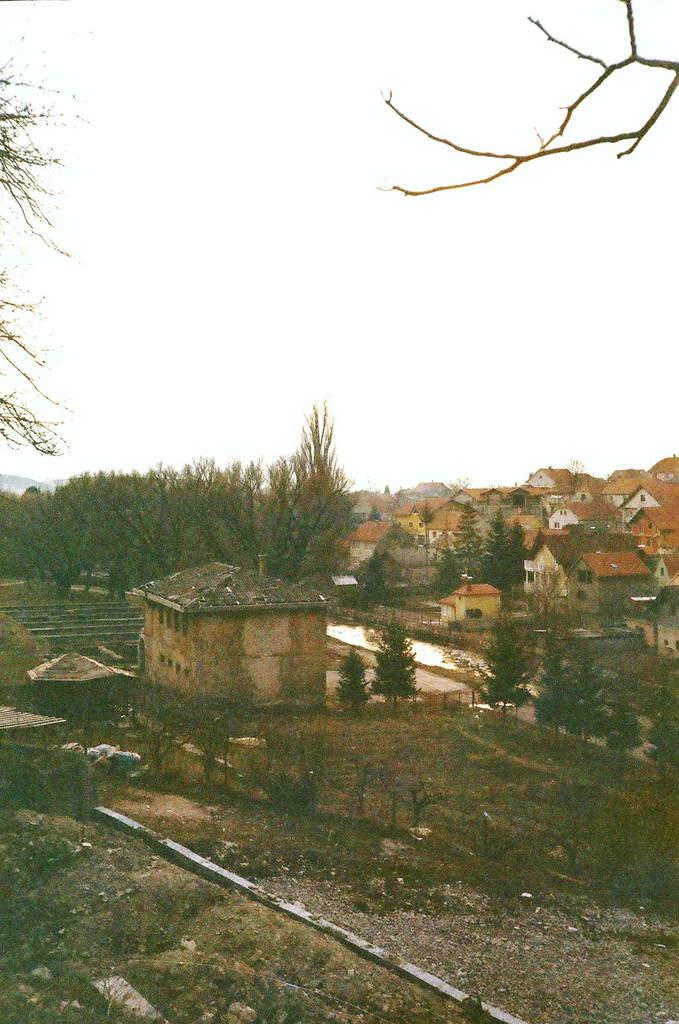What type of vegetation can be seen in the image? There are trees in the image. What type of structures are present in the image? There are houses in the image. What is visible in the sky in the image? The sky is visible in the image. What other objects can be seen in the image? There are objects in the image. How many bikes are visible in the image? There is no bike present in the image. What type of fowl can be seen interacting with the trees in the image? There is no fowl present in the image. What type of bun is visible in the image? There is no bun present in the image. 